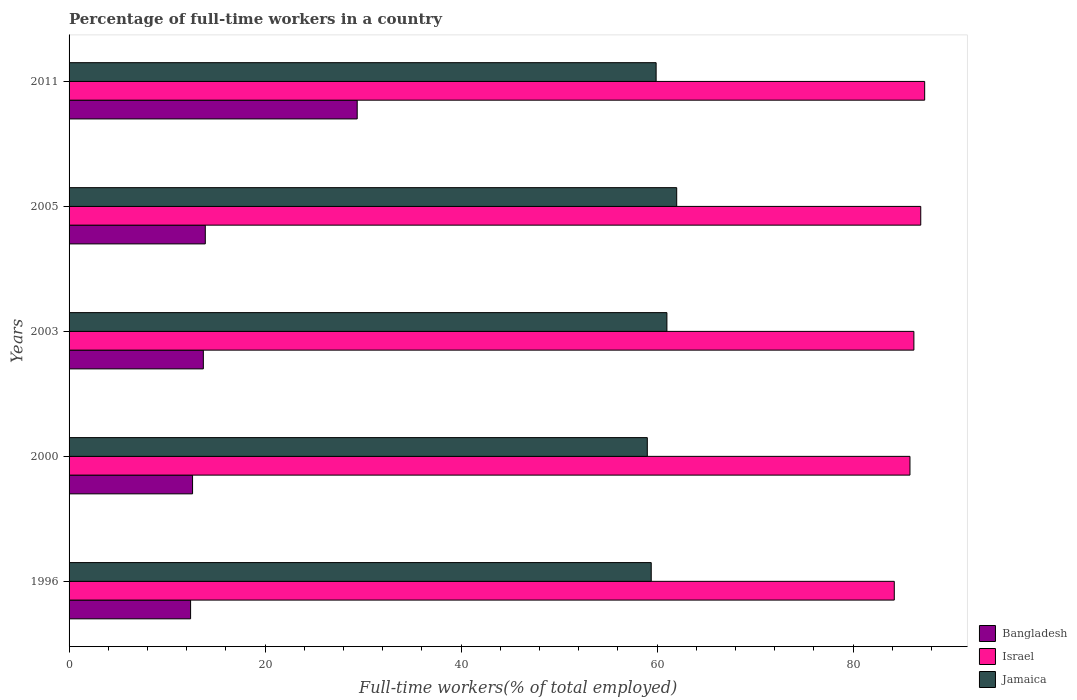How many different coloured bars are there?
Provide a succinct answer. 3. How many groups of bars are there?
Your response must be concise. 5. Are the number of bars on each tick of the Y-axis equal?
Your answer should be compact. Yes. In how many cases, is the number of bars for a given year not equal to the number of legend labels?
Your answer should be very brief. 0. What is the percentage of full-time workers in Israel in 2011?
Offer a terse response. 87.3. Across all years, what is the maximum percentage of full-time workers in Bangladesh?
Your answer should be very brief. 29.4. Across all years, what is the minimum percentage of full-time workers in Israel?
Provide a short and direct response. 84.2. In which year was the percentage of full-time workers in Bangladesh maximum?
Offer a very short reply. 2011. In which year was the percentage of full-time workers in Bangladesh minimum?
Provide a succinct answer. 1996. What is the total percentage of full-time workers in Jamaica in the graph?
Your answer should be compact. 301.3. What is the difference between the percentage of full-time workers in Bangladesh in 2003 and that in 2005?
Offer a very short reply. -0.2. What is the difference between the percentage of full-time workers in Israel in 2005 and the percentage of full-time workers in Jamaica in 2003?
Offer a very short reply. 25.9. What is the average percentage of full-time workers in Jamaica per year?
Offer a terse response. 60.26. In the year 2000, what is the difference between the percentage of full-time workers in Israel and percentage of full-time workers in Bangladesh?
Your answer should be very brief. 73.2. What is the ratio of the percentage of full-time workers in Israel in 2003 to that in 2011?
Keep it short and to the point. 0.99. Is the difference between the percentage of full-time workers in Israel in 2005 and 2011 greater than the difference between the percentage of full-time workers in Bangladesh in 2005 and 2011?
Give a very brief answer. Yes. What is the difference between the highest and the second highest percentage of full-time workers in Israel?
Make the answer very short. 0.4. What is the difference between the highest and the lowest percentage of full-time workers in Israel?
Provide a short and direct response. 3.1. Is the sum of the percentage of full-time workers in Jamaica in 2000 and 2003 greater than the maximum percentage of full-time workers in Israel across all years?
Offer a terse response. Yes. What does the 3rd bar from the top in 1996 represents?
Provide a succinct answer. Bangladesh. Is it the case that in every year, the sum of the percentage of full-time workers in Israel and percentage of full-time workers in Jamaica is greater than the percentage of full-time workers in Bangladesh?
Offer a terse response. Yes. How many bars are there?
Provide a short and direct response. 15. What is the difference between two consecutive major ticks on the X-axis?
Ensure brevity in your answer.  20. Are the values on the major ticks of X-axis written in scientific E-notation?
Your answer should be compact. No. Does the graph contain any zero values?
Give a very brief answer. No. How are the legend labels stacked?
Provide a succinct answer. Vertical. What is the title of the graph?
Provide a succinct answer. Percentage of full-time workers in a country. What is the label or title of the X-axis?
Your response must be concise. Full-time workers(% of total employed). What is the label or title of the Y-axis?
Make the answer very short. Years. What is the Full-time workers(% of total employed) in Bangladesh in 1996?
Ensure brevity in your answer.  12.4. What is the Full-time workers(% of total employed) in Israel in 1996?
Provide a short and direct response. 84.2. What is the Full-time workers(% of total employed) of Jamaica in 1996?
Give a very brief answer. 59.4. What is the Full-time workers(% of total employed) in Bangladesh in 2000?
Provide a short and direct response. 12.6. What is the Full-time workers(% of total employed) of Israel in 2000?
Offer a very short reply. 85.8. What is the Full-time workers(% of total employed) in Jamaica in 2000?
Ensure brevity in your answer.  59. What is the Full-time workers(% of total employed) in Bangladesh in 2003?
Your response must be concise. 13.7. What is the Full-time workers(% of total employed) of Israel in 2003?
Provide a succinct answer. 86.2. What is the Full-time workers(% of total employed) in Jamaica in 2003?
Provide a succinct answer. 61. What is the Full-time workers(% of total employed) in Bangladesh in 2005?
Your response must be concise. 13.9. What is the Full-time workers(% of total employed) in Israel in 2005?
Your answer should be compact. 86.9. What is the Full-time workers(% of total employed) in Jamaica in 2005?
Give a very brief answer. 62. What is the Full-time workers(% of total employed) in Bangladesh in 2011?
Your response must be concise. 29.4. What is the Full-time workers(% of total employed) in Israel in 2011?
Your answer should be very brief. 87.3. What is the Full-time workers(% of total employed) in Jamaica in 2011?
Give a very brief answer. 59.9. Across all years, what is the maximum Full-time workers(% of total employed) of Bangladesh?
Your response must be concise. 29.4. Across all years, what is the maximum Full-time workers(% of total employed) of Israel?
Offer a terse response. 87.3. Across all years, what is the maximum Full-time workers(% of total employed) of Jamaica?
Make the answer very short. 62. Across all years, what is the minimum Full-time workers(% of total employed) of Bangladesh?
Provide a succinct answer. 12.4. Across all years, what is the minimum Full-time workers(% of total employed) in Israel?
Make the answer very short. 84.2. Across all years, what is the minimum Full-time workers(% of total employed) in Jamaica?
Provide a succinct answer. 59. What is the total Full-time workers(% of total employed) in Bangladesh in the graph?
Offer a very short reply. 82. What is the total Full-time workers(% of total employed) of Israel in the graph?
Your answer should be very brief. 430.4. What is the total Full-time workers(% of total employed) of Jamaica in the graph?
Your answer should be very brief. 301.3. What is the difference between the Full-time workers(% of total employed) in Bangladesh in 1996 and that in 2000?
Your response must be concise. -0.2. What is the difference between the Full-time workers(% of total employed) of Israel in 1996 and that in 2000?
Keep it short and to the point. -1.6. What is the difference between the Full-time workers(% of total employed) in Jamaica in 1996 and that in 2000?
Provide a succinct answer. 0.4. What is the difference between the Full-time workers(% of total employed) in Bangladesh in 1996 and that in 2003?
Your answer should be compact. -1.3. What is the difference between the Full-time workers(% of total employed) in Bangladesh in 1996 and that in 2005?
Offer a terse response. -1.5. What is the difference between the Full-time workers(% of total employed) in Jamaica in 1996 and that in 2005?
Provide a short and direct response. -2.6. What is the difference between the Full-time workers(% of total employed) of Bangladesh in 1996 and that in 2011?
Your answer should be very brief. -17. What is the difference between the Full-time workers(% of total employed) in Israel in 2000 and that in 2003?
Offer a terse response. -0.4. What is the difference between the Full-time workers(% of total employed) of Jamaica in 2000 and that in 2003?
Make the answer very short. -2. What is the difference between the Full-time workers(% of total employed) in Bangladesh in 2000 and that in 2005?
Ensure brevity in your answer.  -1.3. What is the difference between the Full-time workers(% of total employed) of Israel in 2000 and that in 2005?
Give a very brief answer. -1.1. What is the difference between the Full-time workers(% of total employed) in Bangladesh in 2000 and that in 2011?
Offer a terse response. -16.8. What is the difference between the Full-time workers(% of total employed) in Israel in 2000 and that in 2011?
Your answer should be very brief. -1.5. What is the difference between the Full-time workers(% of total employed) in Bangladesh in 2003 and that in 2005?
Keep it short and to the point. -0.2. What is the difference between the Full-time workers(% of total employed) of Israel in 2003 and that in 2005?
Offer a very short reply. -0.7. What is the difference between the Full-time workers(% of total employed) of Bangladesh in 2003 and that in 2011?
Keep it short and to the point. -15.7. What is the difference between the Full-time workers(% of total employed) of Israel in 2003 and that in 2011?
Ensure brevity in your answer.  -1.1. What is the difference between the Full-time workers(% of total employed) in Bangladesh in 2005 and that in 2011?
Ensure brevity in your answer.  -15.5. What is the difference between the Full-time workers(% of total employed) in Israel in 2005 and that in 2011?
Give a very brief answer. -0.4. What is the difference between the Full-time workers(% of total employed) in Bangladesh in 1996 and the Full-time workers(% of total employed) in Israel in 2000?
Keep it short and to the point. -73.4. What is the difference between the Full-time workers(% of total employed) in Bangladesh in 1996 and the Full-time workers(% of total employed) in Jamaica in 2000?
Make the answer very short. -46.6. What is the difference between the Full-time workers(% of total employed) of Israel in 1996 and the Full-time workers(% of total employed) of Jamaica in 2000?
Keep it short and to the point. 25.2. What is the difference between the Full-time workers(% of total employed) in Bangladesh in 1996 and the Full-time workers(% of total employed) in Israel in 2003?
Ensure brevity in your answer.  -73.8. What is the difference between the Full-time workers(% of total employed) of Bangladesh in 1996 and the Full-time workers(% of total employed) of Jamaica in 2003?
Keep it short and to the point. -48.6. What is the difference between the Full-time workers(% of total employed) of Israel in 1996 and the Full-time workers(% of total employed) of Jamaica in 2003?
Your response must be concise. 23.2. What is the difference between the Full-time workers(% of total employed) in Bangladesh in 1996 and the Full-time workers(% of total employed) in Israel in 2005?
Your answer should be very brief. -74.5. What is the difference between the Full-time workers(% of total employed) of Bangladesh in 1996 and the Full-time workers(% of total employed) of Jamaica in 2005?
Provide a succinct answer. -49.6. What is the difference between the Full-time workers(% of total employed) in Bangladesh in 1996 and the Full-time workers(% of total employed) in Israel in 2011?
Provide a succinct answer. -74.9. What is the difference between the Full-time workers(% of total employed) of Bangladesh in 1996 and the Full-time workers(% of total employed) of Jamaica in 2011?
Provide a short and direct response. -47.5. What is the difference between the Full-time workers(% of total employed) in Israel in 1996 and the Full-time workers(% of total employed) in Jamaica in 2011?
Ensure brevity in your answer.  24.3. What is the difference between the Full-time workers(% of total employed) in Bangladesh in 2000 and the Full-time workers(% of total employed) in Israel in 2003?
Keep it short and to the point. -73.6. What is the difference between the Full-time workers(% of total employed) of Bangladesh in 2000 and the Full-time workers(% of total employed) of Jamaica in 2003?
Your answer should be very brief. -48.4. What is the difference between the Full-time workers(% of total employed) of Israel in 2000 and the Full-time workers(% of total employed) of Jamaica in 2003?
Your answer should be very brief. 24.8. What is the difference between the Full-time workers(% of total employed) of Bangladesh in 2000 and the Full-time workers(% of total employed) of Israel in 2005?
Your answer should be compact. -74.3. What is the difference between the Full-time workers(% of total employed) of Bangladesh in 2000 and the Full-time workers(% of total employed) of Jamaica in 2005?
Give a very brief answer. -49.4. What is the difference between the Full-time workers(% of total employed) of Israel in 2000 and the Full-time workers(% of total employed) of Jamaica in 2005?
Give a very brief answer. 23.8. What is the difference between the Full-time workers(% of total employed) in Bangladesh in 2000 and the Full-time workers(% of total employed) in Israel in 2011?
Ensure brevity in your answer.  -74.7. What is the difference between the Full-time workers(% of total employed) in Bangladesh in 2000 and the Full-time workers(% of total employed) in Jamaica in 2011?
Offer a terse response. -47.3. What is the difference between the Full-time workers(% of total employed) in Israel in 2000 and the Full-time workers(% of total employed) in Jamaica in 2011?
Offer a terse response. 25.9. What is the difference between the Full-time workers(% of total employed) of Bangladesh in 2003 and the Full-time workers(% of total employed) of Israel in 2005?
Provide a short and direct response. -73.2. What is the difference between the Full-time workers(% of total employed) in Bangladesh in 2003 and the Full-time workers(% of total employed) in Jamaica in 2005?
Give a very brief answer. -48.3. What is the difference between the Full-time workers(% of total employed) in Israel in 2003 and the Full-time workers(% of total employed) in Jamaica in 2005?
Provide a succinct answer. 24.2. What is the difference between the Full-time workers(% of total employed) in Bangladesh in 2003 and the Full-time workers(% of total employed) in Israel in 2011?
Make the answer very short. -73.6. What is the difference between the Full-time workers(% of total employed) of Bangladesh in 2003 and the Full-time workers(% of total employed) of Jamaica in 2011?
Your answer should be very brief. -46.2. What is the difference between the Full-time workers(% of total employed) of Israel in 2003 and the Full-time workers(% of total employed) of Jamaica in 2011?
Offer a very short reply. 26.3. What is the difference between the Full-time workers(% of total employed) of Bangladesh in 2005 and the Full-time workers(% of total employed) of Israel in 2011?
Give a very brief answer. -73.4. What is the difference between the Full-time workers(% of total employed) of Bangladesh in 2005 and the Full-time workers(% of total employed) of Jamaica in 2011?
Your response must be concise. -46. What is the difference between the Full-time workers(% of total employed) in Israel in 2005 and the Full-time workers(% of total employed) in Jamaica in 2011?
Ensure brevity in your answer.  27. What is the average Full-time workers(% of total employed) of Bangladesh per year?
Keep it short and to the point. 16.4. What is the average Full-time workers(% of total employed) of Israel per year?
Your answer should be compact. 86.08. What is the average Full-time workers(% of total employed) of Jamaica per year?
Offer a very short reply. 60.26. In the year 1996, what is the difference between the Full-time workers(% of total employed) of Bangladesh and Full-time workers(% of total employed) of Israel?
Offer a very short reply. -71.8. In the year 1996, what is the difference between the Full-time workers(% of total employed) in Bangladesh and Full-time workers(% of total employed) in Jamaica?
Your answer should be compact. -47. In the year 1996, what is the difference between the Full-time workers(% of total employed) in Israel and Full-time workers(% of total employed) in Jamaica?
Provide a short and direct response. 24.8. In the year 2000, what is the difference between the Full-time workers(% of total employed) of Bangladesh and Full-time workers(% of total employed) of Israel?
Your answer should be very brief. -73.2. In the year 2000, what is the difference between the Full-time workers(% of total employed) in Bangladesh and Full-time workers(% of total employed) in Jamaica?
Your answer should be very brief. -46.4. In the year 2000, what is the difference between the Full-time workers(% of total employed) of Israel and Full-time workers(% of total employed) of Jamaica?
Your answer should be compact. 26.8. In the year 2003, what is the difference between the Full-time workers(% of total employed) of Bangladesh and Full-time workers(% of total employed) of Israel?
Your answer should be compact. -72.5. In the year 2003, what is the difference between the Full-time workers(% of total employed) of Bangladesh and Full-time workers(% of total employed) of Jamaica?
Provide a succinct answer. -47.3. In the year 2003, what is the difference between the Full-time workers(% of total employed) of Israel and Full-time workers(% of total employed) of Jamaica?
Give a very brief answer. 25.2. In the year 2005, what is the difference between the Full-time workers(% of total employed) of Bangladesh and Full-time workers(% of total employed) of Israel?
Ensure brevity in your answer.  -73. In the year 2005, what is the difference between the Full-time workers(% of total employed) in Bangladesh and Full-time workers(% of total employed) in Jamaica?
Offer a terse response. -48.1. In the year 2005, what is the difference between the Full-time workers(% of total employed) of Israel and Full-time workers(% of total employed) of Jamaica?
Provide a succinct answer. 24.9. In the year 2011, what is the difference between the Full-time workers(% of total employed) in Bangladesh and Full-time workers(% of total employed) in Israel?
Keep it short and to the point. -57.9. In the year 2011, what is the difference between the Full-time workers(% of total employed) in Bangladesh and Full-time workers(% of total employed) in Jamaica?
Your response must be concise. -30.5. In the year 2011, what is the difference between the Full-time workers(% of total employed) in Israel and Full-time workers(% of total employed) in Jamaica?
Your answer should be compact. 27.4. What is the ratio of the Full-time workers(% of total employed) in Bangladesh in 1996 to that in 2000?
Keep it short and to the point. 0.98. What is the ratio of the Full-time workers(% of total employed) of Israel in 1996 to that in 2000?
Ensure brevity in your answer.  0.98. What is the ratio of the Full-time workers(% of total employed) of Jamaica in 1996 to that in 2000?
Make the answer very short. 1.01. What is the ratio of the Full-time workers(% of total employed) in Bangladesh in 1996 to that in 2003?
Offer a terse response. 0.91. What is the ratio of the Full-time workers(% of total employed) of Israel in 1996 to that in 2003?
Offer a very short reply. 0.98. What is the ratio of the Full-time workers(% of total employed) in Jamaica in 1996 to that in 2003?
Offer a very short reply. 0.97. What is the ratio of the Full-time workers(% of total employed) in Bangladesh in 1996 to that in 2005?
Your response must be concise. 0.89. What is the ratio of the Full-time workers(% of total employed) of Israel in 1996 to that in 2005?
Your response must be concise. 0.97. What is the ratio of the Full-time workers(% of total employed) in Jamaica in 1996 to that in 2005?
Your response must be concise. 0.96. What is the ratio of the Full-time workers(% of total employed) in Bangladesh in 1996 to that in 2011?
Give a very brief answer. 0.42. What is the ratio of the Full-time workers(% of total employed) of Israel in 1996 to that in 2011?
Provide a short and direct response. 0.96. What is the ratio of the Full-time workers(% of total employed) of Jamaica in 1996 to that in 2011?
Your response must be concise. 0.99. What is the ratio of the Full-time workers(% of total employed) in Bangladesh in 2000 to that in 2003?
Provide a short and direct response. 0.92. What is the ratio of the Full-time workers(% of total employed) of Israel in 2000 to that in 2003?
Keep it short and to the point. 1. What is the ratio of the Full-time workers(% of total employed) in Jamaica in 2000 to that in 2003?
Offer a very short reply. 0.97. What is the ratio of the Full-time workers(% of total employed) of Bangladesh in 2000 to that in 2005?
Offer a terse response. 0.91. What is the ratio of the Full-time workers(% of total employed) of Israel in 2000 to that in 2005?
Keep it short and to the point. 0.99. What is the ratio of the Full-time workers(% of total employed) of Jamaica in 2000 to that in 2005?
Give a very brief answer. 0.95. What is the ratio of the Full-time workers(% of total employed) of Bangladesh in 2000 to that in 2011?
Ensure brevity in your answer.  0.43. What is the ratio of the Full-time workers(% of total employed) in Israel in 2000 to that in 2011?
Your answer should be compact. 0.98. What is the ratio of the Full-time workers(% of total employed) of Bangladesh in 2003 to that in 2005?
Give a very brief answer. 0.99. What is the ratio of the Full-time workers(% of total employed) in Israel in 2003 to that in 2005?
Make the answer very short. 0.99. What is the ratio of the Full-time workers(% of total employed) of Jamaica in 2003 to that in 2005?
Give a very brief answer. 0.98. What is the ratio of the Full-time workers(% of total employed) in Bangladesh in 2003 to that in 2011?
Your response must be concise. 0.47. What is the ratio of the Full-time workers(% of total employed) of Israel in 2003 to that in 2011?
Your answer should be very brief. 0.99. What is the ratio of the Full-time workers(% of total employed) in Jamaica in 2003 to that in 2011?
Your answer should be compact. 1.02. What is the ratio of the Full-time workers(% of total employed) in Bangladesh in 2005 to that in 2011?
Provide a succinct answer. 0.47. What is the ratio of the Full-time workers(% of total employed) in Israel in 2005 to that in 2011?
Keep it short and to the point. 1. What is the ratio of the Full-time workers(% of total employed) of Jamaica in 2005 to that in 2011?
Your answer should be compact. 1.04. What is the difference between the highest and the second highest Full-time workers(% of total employed) in Israel?
Give a very brief answer. 0.4. What is the difference between the highest and the second highest Full-time workers(% of total employed) of Jamaica?
Your answer should be very brief. 1. What is the difference between the highest and the lowest Full-time workers(% of total employed) in Bangladesh?
Provide a short and direct response. 17. What is the difference between the highest and the lowest Full-time workers(% of total employed) of Jamaica?
Make the answer very short. 3. 